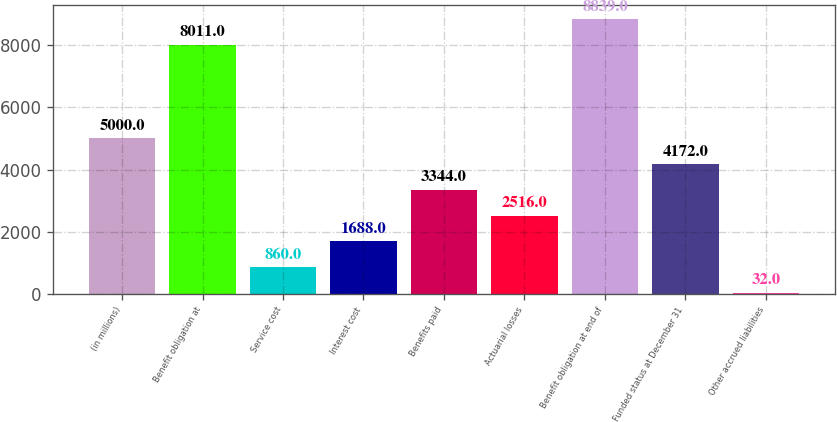<chart> <loc_0><loc_0><loc_500><loc_500><bar_chart><fcel>(in millions)<fcel>Benefit obligation at<fcel>Service cost<fcel>Interest cost<fcel>Benefits paid<fcel>Actuarial losses<fcel>Benefit obligation at end of<fcel>Funded status at December 31<fcel>Other accrued liabilities<nl><fcel>5000<fcel>8011<fcel>860<fcel>1688<fcel>3344<fcel>2516<fcel>8839<fcel>4172<fcel>32<nl></chart> 